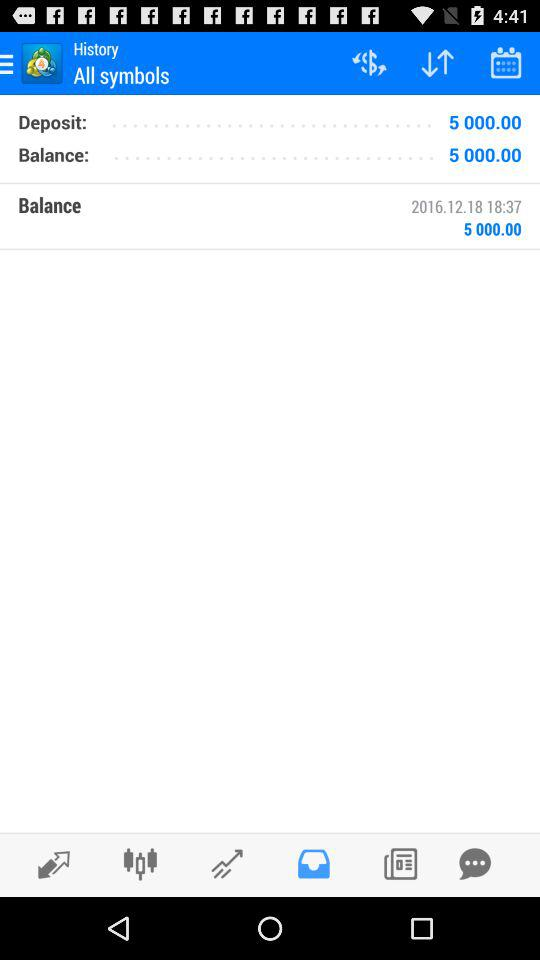What is the time? The time is 18:37. 